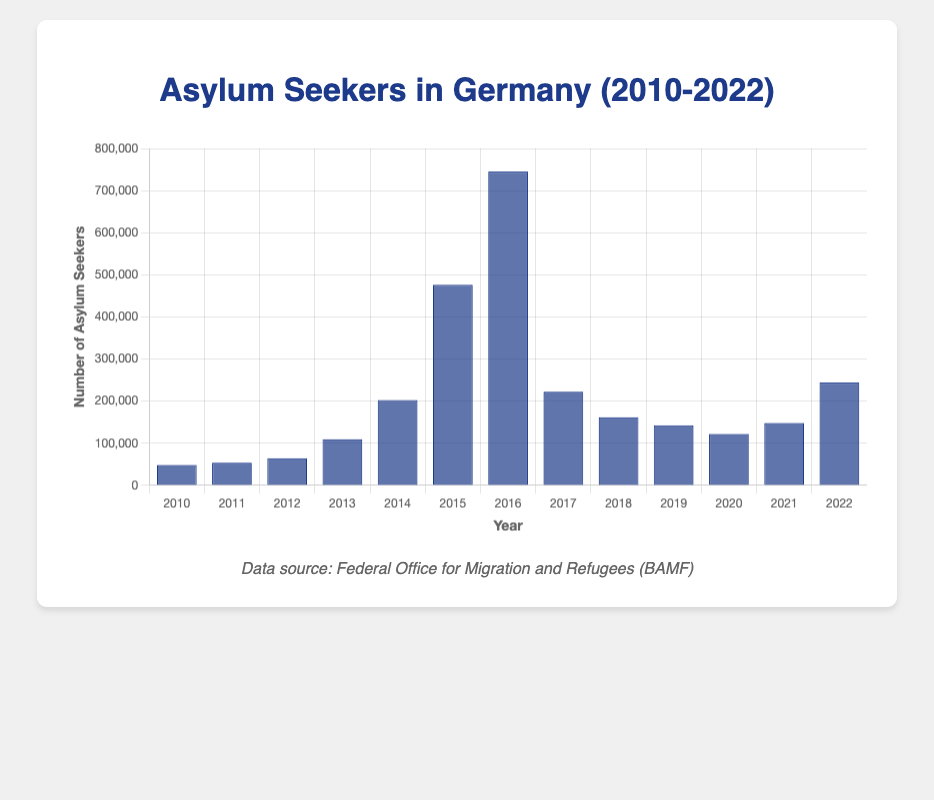What is the total number of asylum seekers in Germany for the years 2010 to 2014? The total number of asylum seekers between 2010 and 2014 can be calculated by summing the numbers for each year in this range: 48500 (2010) + 53800 (2011) + 64500 (2012) + 109580 (2013) + 202645 (2014). The total is 479025.
Answer: 479025 Between which two consecutive years did the number of asylum seekers increase the most? By visually comparing the increases between each consecutive pair of years, the largest increase occurs between 2014 and 2015, where the number of asylum seekers jumps from 202645 to 476620, an increase of 273975.
Answer: 2014 to 2015 In which year did Germany receive the highest number of asylum seekers? By examining the height of the bars, the year 2016 has the highest bar, indicating that it had the highest number of asylum seekers at 745545.
Answer: 2016 What is the average annual number of asylum seekers from 2010 to 2022? To find the average, sum the numbers from each year from 2010 to 2022 and divide by the number of years: (48500 + 53800 + 64500 + 109580 + 202645 + 476620 + 745545 + 222560 + 161930 + 142510 + 122170 + 148230 + 244130) / 13 gives approximately 218330.
Answer: 218330 By how much did the number of asylum seekers decrease from 2016 to 2017? Subtract the number of asylum seekers in 2017 from the number in 2016: 745545 (2016) - 222560 (2017) is 522985.
Answer: 522985 How does the number of asylum seekers in 2020 compare to 2018? Comparing the heights of the bars for the years 2020 and 2018, the bar for 2020 represents 122170 seekers and the bar for 2018 represents 161930 seekers, showing there were fewer asylum seekers in 2020 compared to 2018 by 39760.
Answer: 2020 had 39760 fewer than 2018 Which year had a smaller number of asylum seekers: 2012 or 2011? By visually comparing the heights of the bars representing 2012 and 2011, the bar for 2011 is lower. The number of asylum seekers in 2011 was 53800, while in 2012 it was 64500.
Answer: 2011 What is the difference between the highest and lowest annual number of asylum seekers? The highest number is 745545 in 2016, and the lowest number is 48500 in 2010. Subtracting the lowest from the highest yields 745545 - 48500 = 697045.
Answer: 697045 What is the percentage increase in the number of asylum seekers from 2011 to 2012? First, find the difference in numbers between 2012 and 2011: 64500 - 53800 = 10700. Then divide by the 2011 figure and multiply by 100 to get the percentage: (10700 / 53800) * 100 = 19.89%.
Answer: 19.89% What is the median number of asylum seekers during the years 2010-2022? To find the median, list the numbers in order and find the middle value. Sorted: [48500, 53800, 64500, 109580, 122170, 142510, 148230, 161930, 202645, 222560, 244130, 476620, 745545]. The median is the 7th value: 148230.
Answer: 148230 